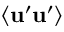<formula> <loc_0><loc_0><loc_500><loc_500>\langle u ^ { \prime } u ^ { \prime } \rangle</formula> 